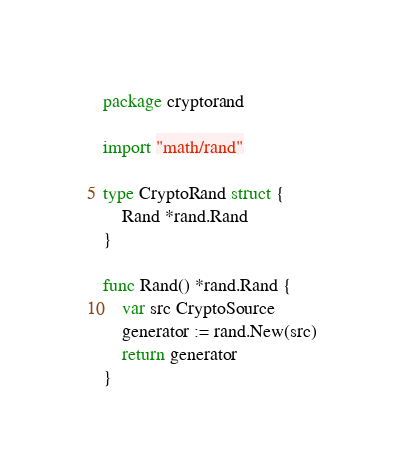<code> <loc_0><loc_0><loc_500><loc_500><_Go_>package cryptorand

import "math/rand"

type CryptoRand struct {
	Rand *rand.Rand
}

func Rand() *rand.Rand {
	var src CryptoSource
	generator := rand.New(src)
	return generator
}
</code> 